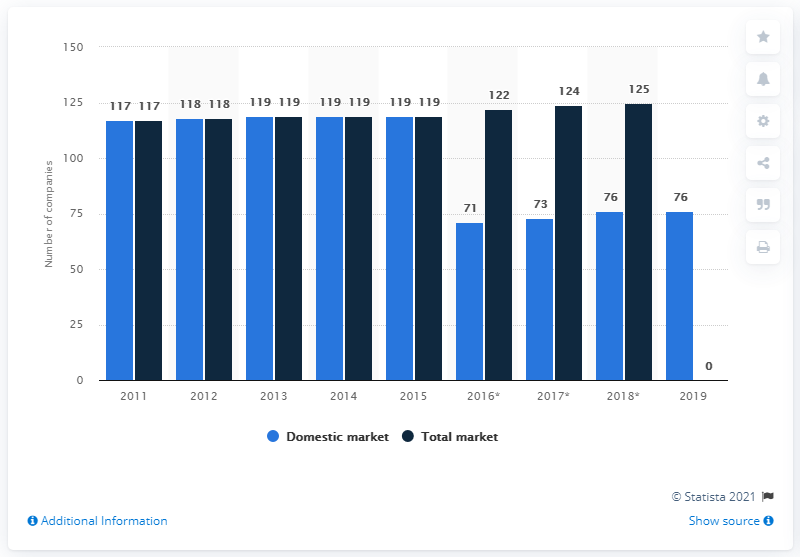Point out several critical features in this image. There were 76 insurance companies operating on the Norwegian market in 2019. 